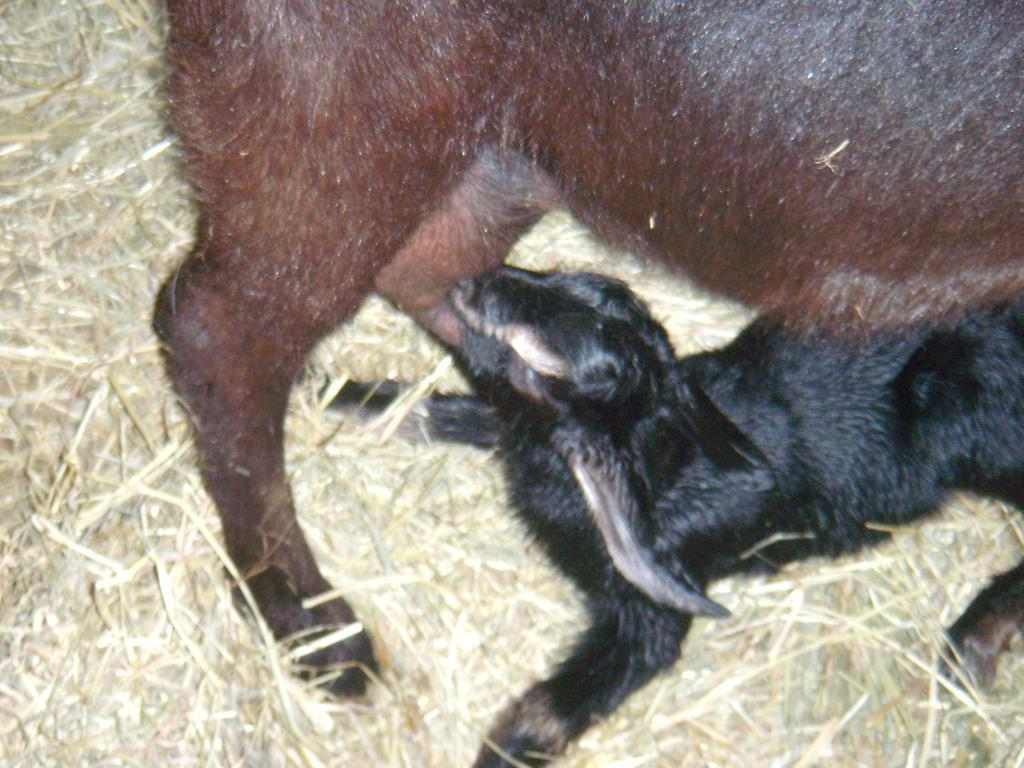How many animals are present in the image? There are two animals in the image. What type of vegetation can be seen in the image? There is dried grass in the image. What type of rod can be seen on the page in the image? There is no page or rod present in the image; it features two animals and dried grass. 